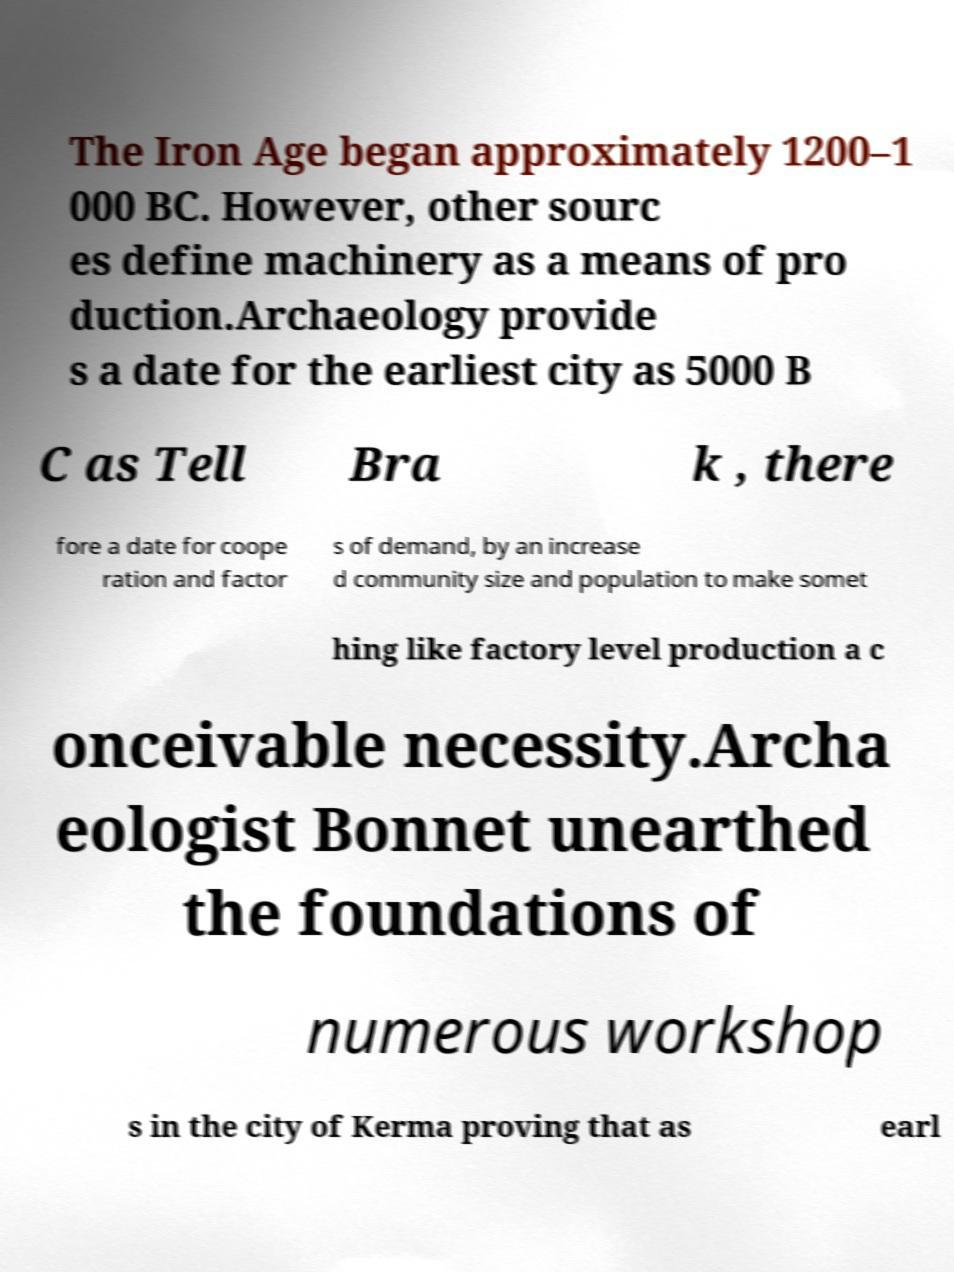For documentation purposes, I need the text within this image transcribed. Could you provide that? The Iron Age began approximately 1200–1 000 BC. However, other sourc es define machinery as a means of pro duction.Archaeology provide s a date for the earliest city as 5000 B C as Tell Bra k , there fore a date for coope ration and factor s of demand, by an increase d community size and population to make somet hing like factory level production a c onceivable necessity.Archa eologist Bonnet unearthed the foundations of numerous workshop s in the city of Kerma proving that as earl 